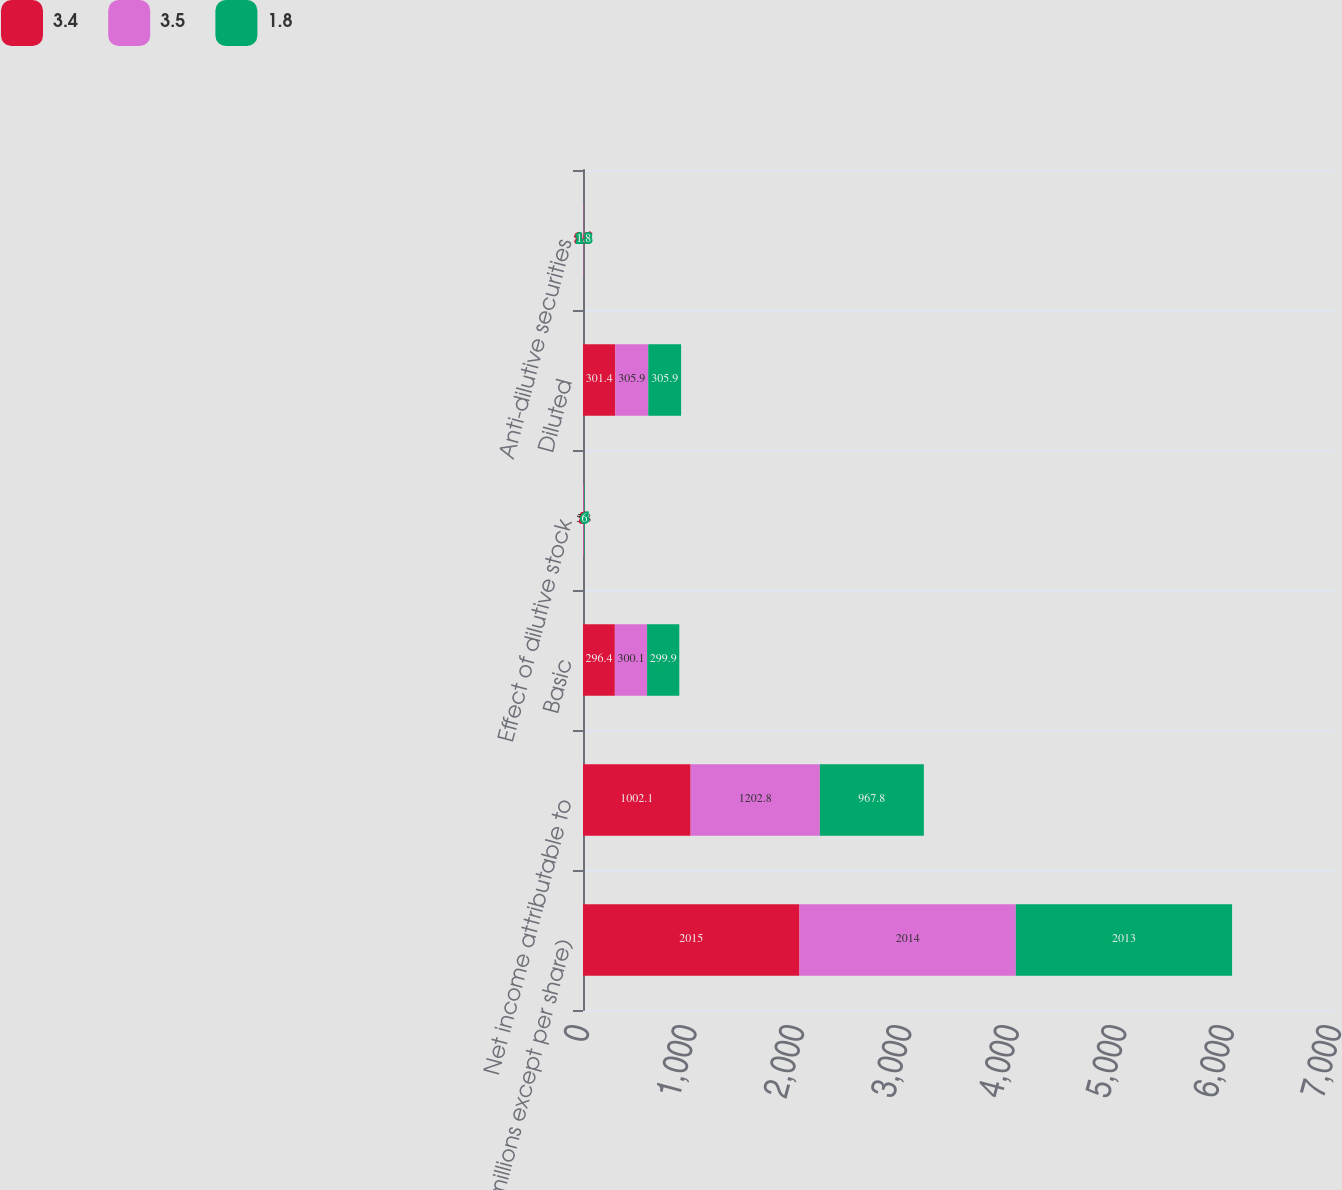<chart> <loc_0><loc_0><loc_500><loc_500><stacked_bar_chart><ecel><fcel>(millions except per share)<fcel>Net income attributable to<fcel>Basic<fcel>Effect of dilutive stock<fcel>Diluted<fcel>Anti-dilutive securities<nl><fcel>3.4<fcel>2015<fcel>1002.1<fcel>296.4<fcel>5<fcel>301.4<fcel>3.5<nl><fcel>3.5<fcel>2014<fcel>1202.8<fcel>300.1<fcel>5.8<fcel>305.9<fcel>3.4<nl><fcel>1.8<fcel>2013<fcel>967.8<fcel>299.9<fcel>6<fcel>305.9<fcel>1.8<nl></chart> 